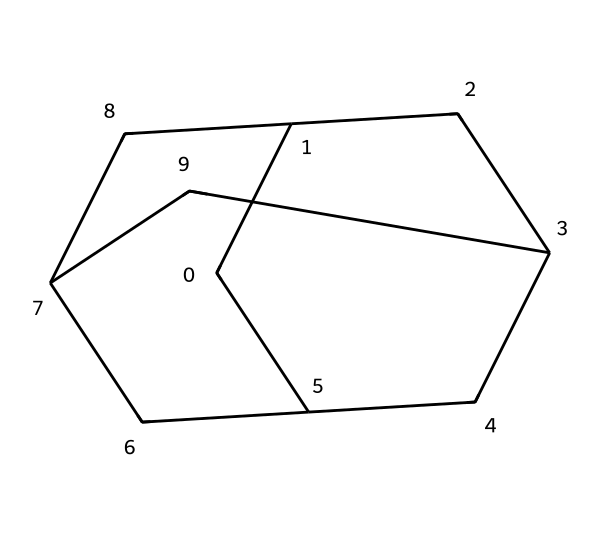What is the name of this compound? The SMILES representation identifies the compound as adamantane, which is a well-known structure in organic chemistry.
Answer: adamantane How many carbon atoms are in the structure? By counting the carbon atoms in the SMILES representation, there are a total of 10 carbon atoms present in the adamantane structure.
Answer: 10 What type of structure does adamantane represent? Adamantane represents a cage structure, characterized by its rigid three-dimensional framework formed by interconnected carbon atoms.
Answer: cage What is the typical use of adamantane in industry? Adamantane is commonly used in wood preservatives due to its stability and ability to protect against decay and insects.
Answer: wood preservatives How many hydrogen atoms would be attached to this structure? Each carbon atom in a saturated hydrocarbon like adamantane is typically bonded to enough hydrogen atoms to satisfy the tetravalence of carbon. For adamantane, there are 14 hydrogen atoms.
Answer: 14 What characteristic of adamantane makes it suitable for wood preservation? The cage-like structure of adamantane provides stability and resistance to degradation, making it effective in wood preservation applications.
Answer: stability Which type of bonding is primarily found in adamantane? The bonding in adamantane is primarily covalent, as carbon atoms share electrons to form stable bonds in the structure.
Answer: covalent 